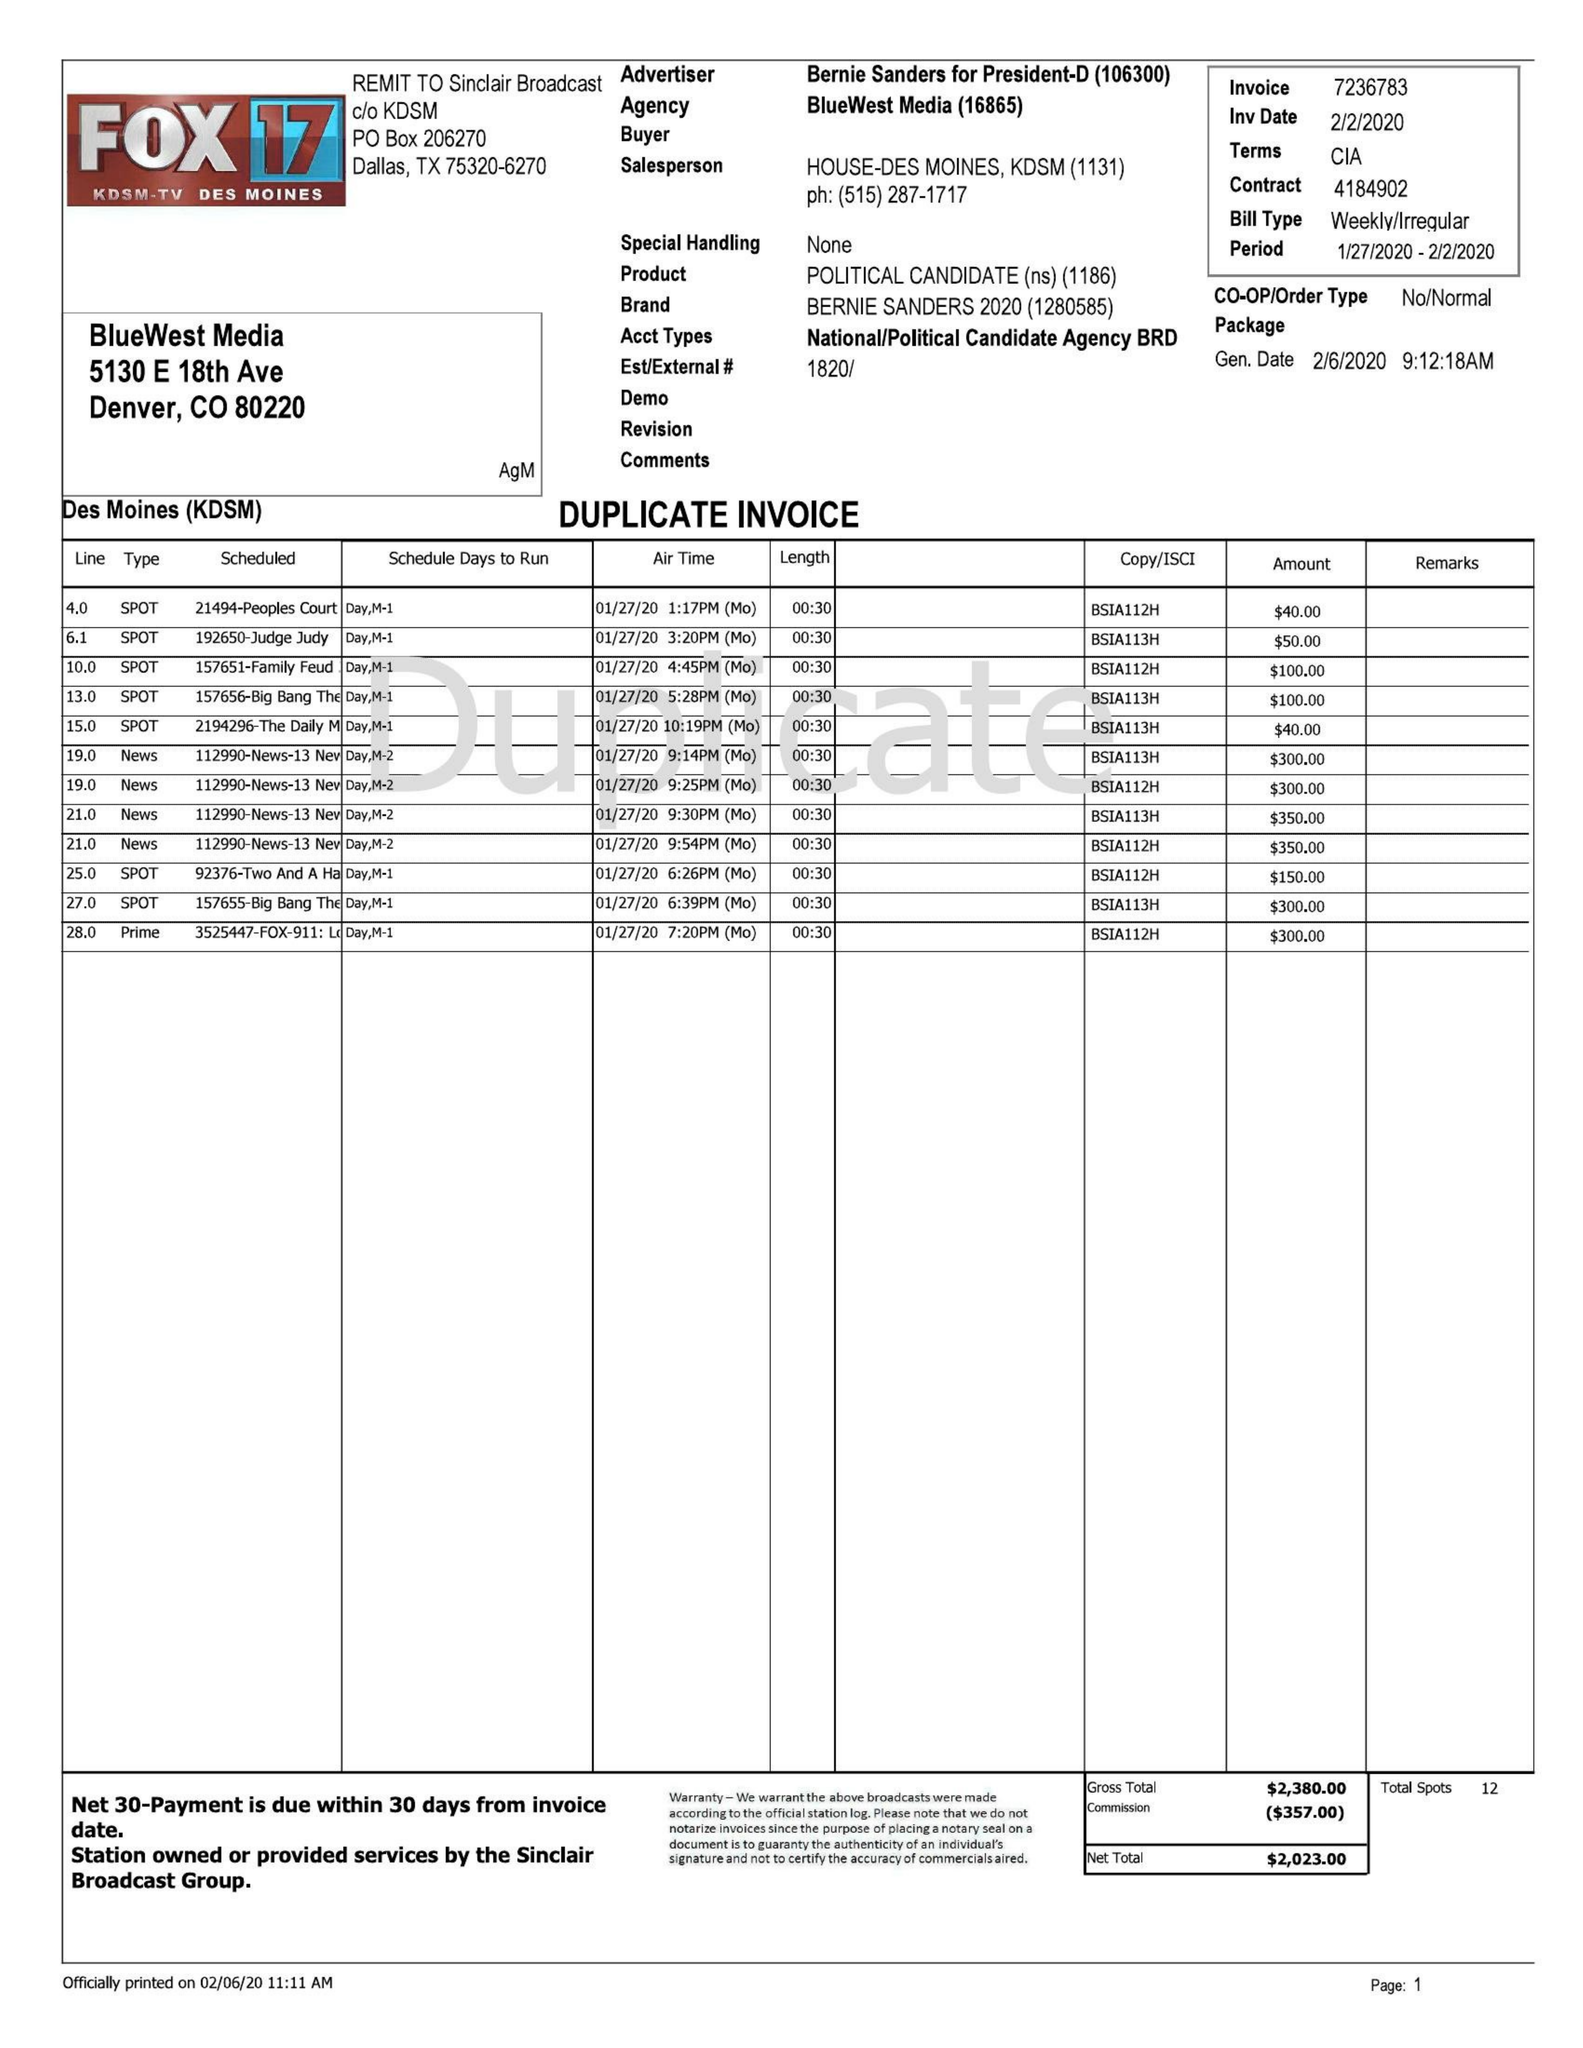What is the value for the flight_from?
Answer the question using a single word or phrase. 01/27/20 